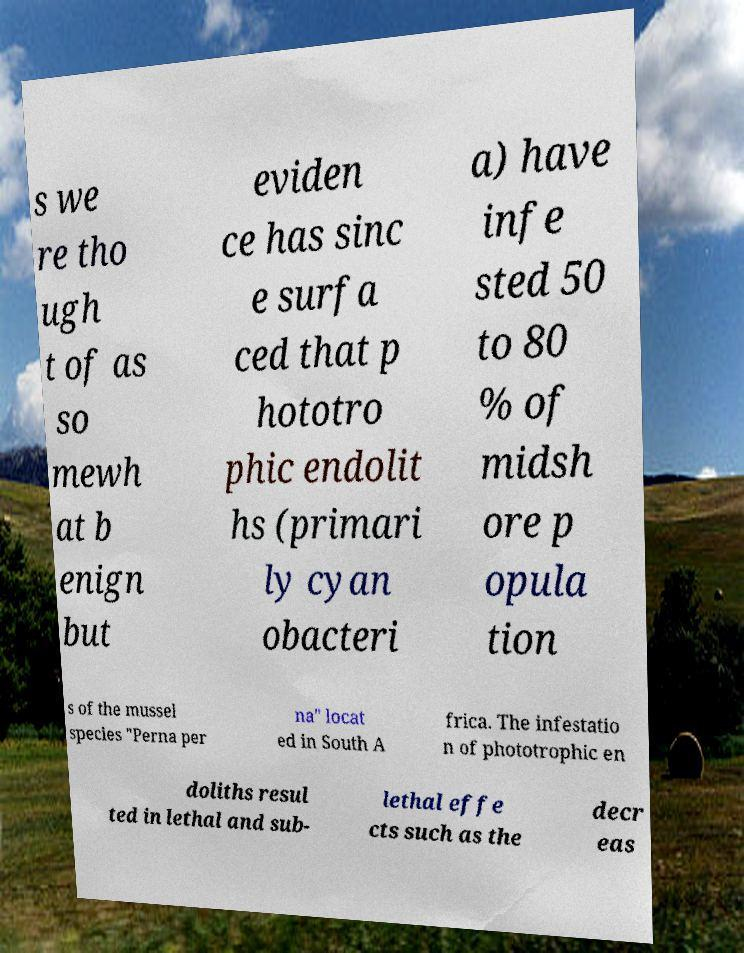I need the written content from this picture converted into text. Can you do that? s we re tho ugh t of as so mewh at b enign but eviden ce has sinc e surfa ced that p hototro phic endolit hs (primari ly cyan obacteri a) have infe sted 50 to 80 % of midsh ore p opula tion s of the mussel species "Perna per na" locat ed in South A frica. The infestatio n of phototrophic en doliths resul ted in lethal and sub- lethal effe cts such as the decr eas 